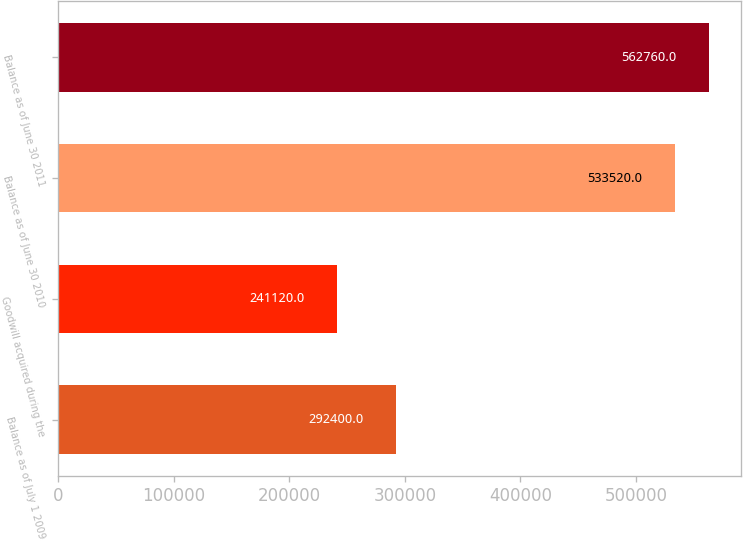<chart> <loc_0><loc_0><loc_500><loc_500><bar_chart><fcel>Balance as of July 1 2009<fcel>Goodwill acquired during the<fcel>Balance as of June 30 2010<fcel>Balance as of June 30 2011<nl><fcel>292400<fcel>241120<fcel>533520<fcel>562760<nl></chart> 